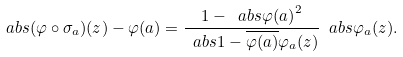<formula> <loc_0><loc_0><loc_500><loc_500>\ a b s { ( \varphi \circ \sigma _ { a } ) ( z ) - \varphi ( a ) } = \frac { 1 - \ a b s { \varphi ( a ) } ^ { 2 } } { \ a b s { 1 - \overline { \varphi ( a ) } \varphi _ { a } ( z ) } } \ a b s { \varphi _ { a } ( z ) } .</formula> 